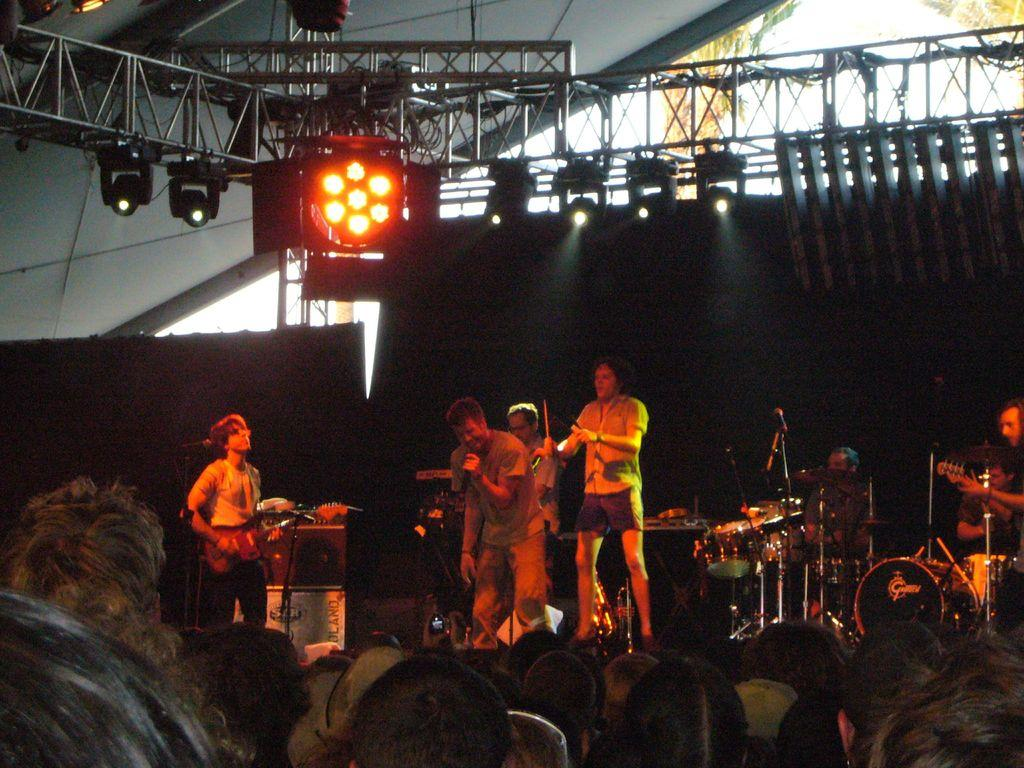What is happening on the stage in the image? There are people on the stage, and they are playing music. What is the role of the person with the microphone? One person is singing into a microphone. Who else is present in the image besides the people on the stage? There are other people watching the show. How many pets are visible on the stage in the image? There are no pets visible on the stage in the image. What unit of measurement is used to determine the size of the land in the image? There is no reference to land or a unit of measurement in the image. 